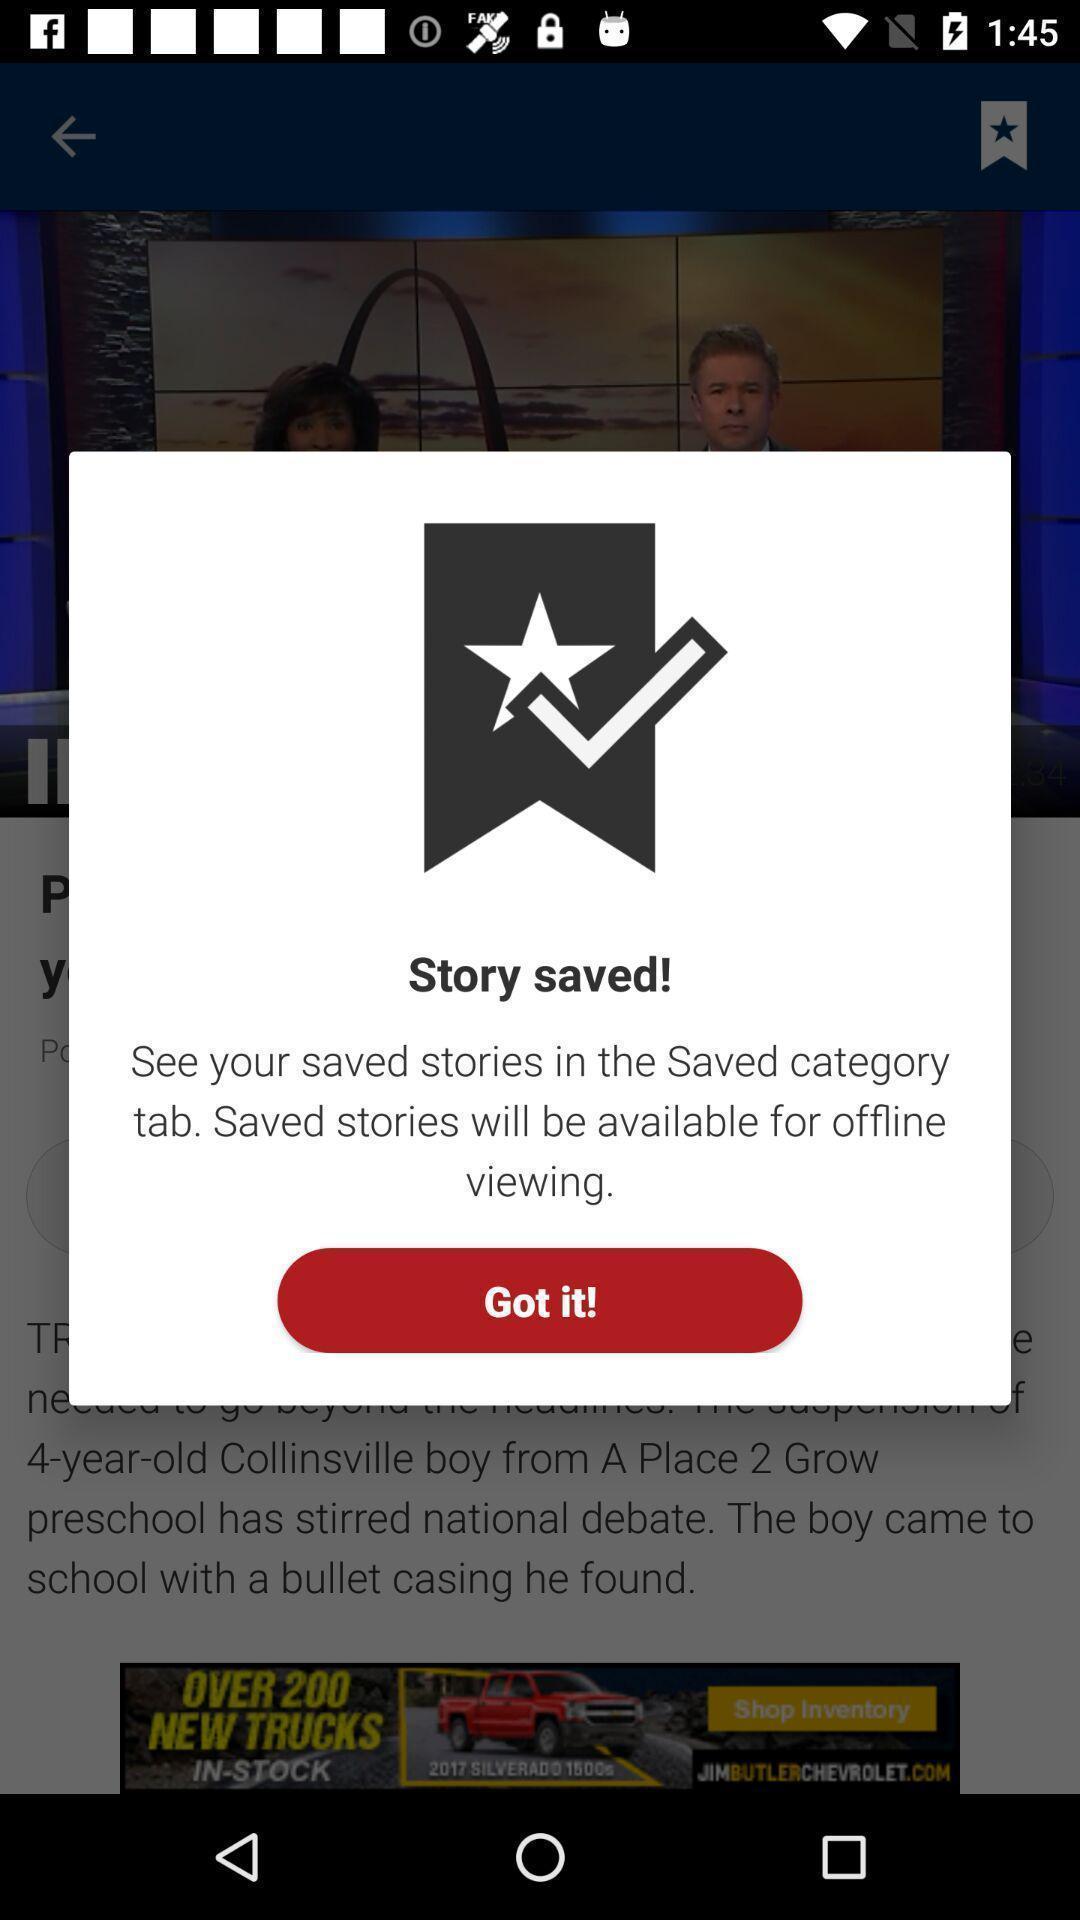Tell me about the visual elements in this screen capture. Popup showing about saved story. 